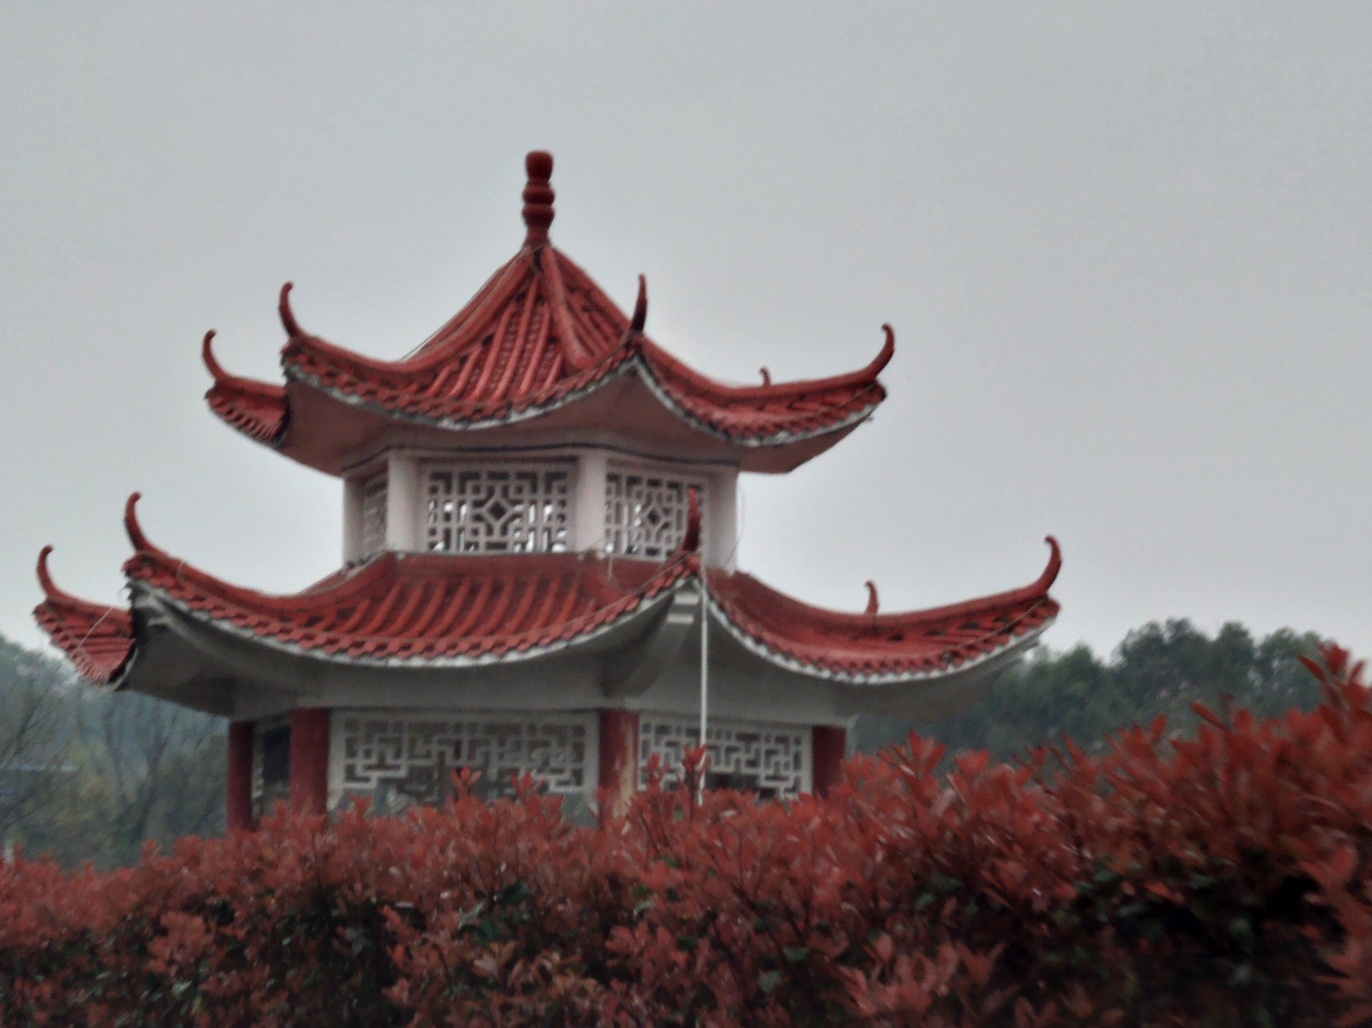What might the weather be like judging from the image? The overcast sky and subdued lighting suggest an overcast or misty day, which could indicate cooler temperatures and high humidity, typical of a foggy or rainy climate. 